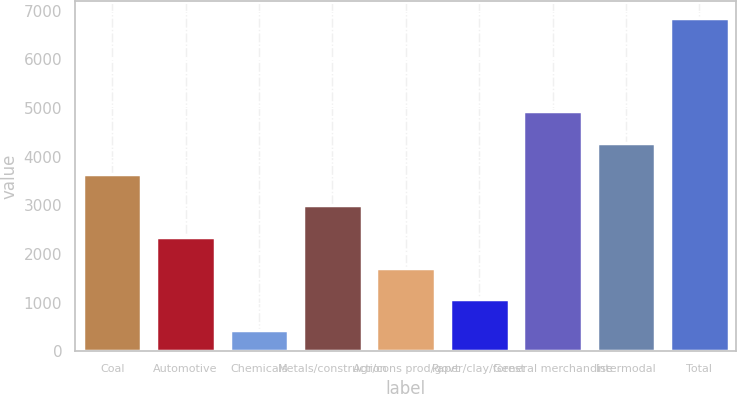Convert chart to OTSL. <chart><loc_0><loc_0><loc_500><loc_500><bar_chart><fcel>Coal<fcel>Automotive<fcel>Chemicals<fcel>Metals/construction<fcel>Agr/cons prod/govt<fcel>Paper/clay/forest<fcel>General merchandise<fcel>Intermodal<fcel>Total<nl><fcel>3643.5<fcel>2356.5<fcel>426<fcel>3000<fcel>1713<fcel>1069.5<fcel>4930.5<fcel>4287<fcel>6861<nl></chart> 